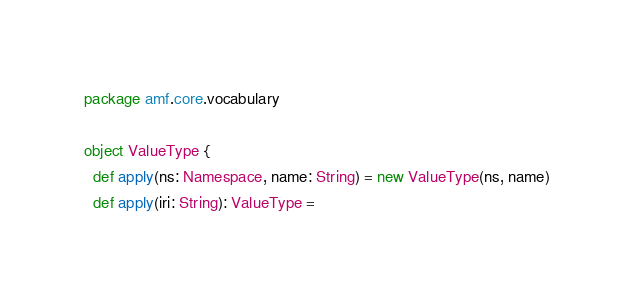Convert code to text. <code><loc_0><loc_0><loc_500><loc_500><_Scala_>package amf.core.vocabulary

object ValueType {
  def apply(ns: Namespace, name: String) = new ValueType(ns, name)
  def apply(iri: String): ValueType =</code> 